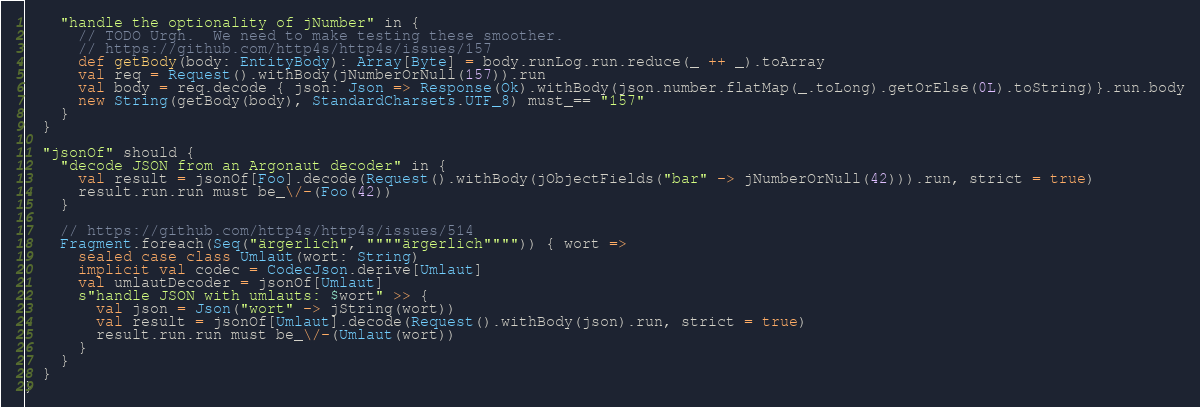<code> <loc_0><loc_0><loc_500><loc_500><_Scala_>    "handle the optionality of jNumber" in {
      // TODO Urgh.  We need to make testing these smoother.
      // https://github.com/http4s/http4s/issues/157
      def getBody(body: EntityBody): Array[Byte] = body.runLog.run.reduce(_ ++ _).toArray
      val req = Request().withBody(jNumberOrNull(157)).run
      val body = req.decode { json: Json => Response(Ok).withBody(json.number.flatMap(_.toLong).getOrElse(0L).toString)}.run.body
      new String(getBody(body), StandardCharsets.UTF_8) must_== "157"
    }
  }

  "jsonOf" should {
    "decode JSON from an Argonaut decoder" in {
      val result = jsonOf[Foo].decode(Request().withBody(jObjectFields("bar" -> jNumberOrNull(42))).run, strict = true)
      result.run.run must be_\/-(Foo(42))
    }

    // https://github.com/http4s/http4s/issues/514
    Fragment.foreach(Seq("ärgerlich", """"ärgerlich"""")) { wort =>
      sealed case class Umlaut(wort: String)
      implicit val codec = CodecJson.derive[Umlaut]
      val umlautDecoder = jsonOf[Umlaut]
      s"handle JSON with umlauts: $wort" >> {
        val json = Json("wort" -> jString(wort))
        val result = jsonOf[Umlaut].decode(Request().withBody(json).run, strict = true)
        result.run.run must be_\/-(Umlaut(wort))
      }
    }
  }
}
</code> 